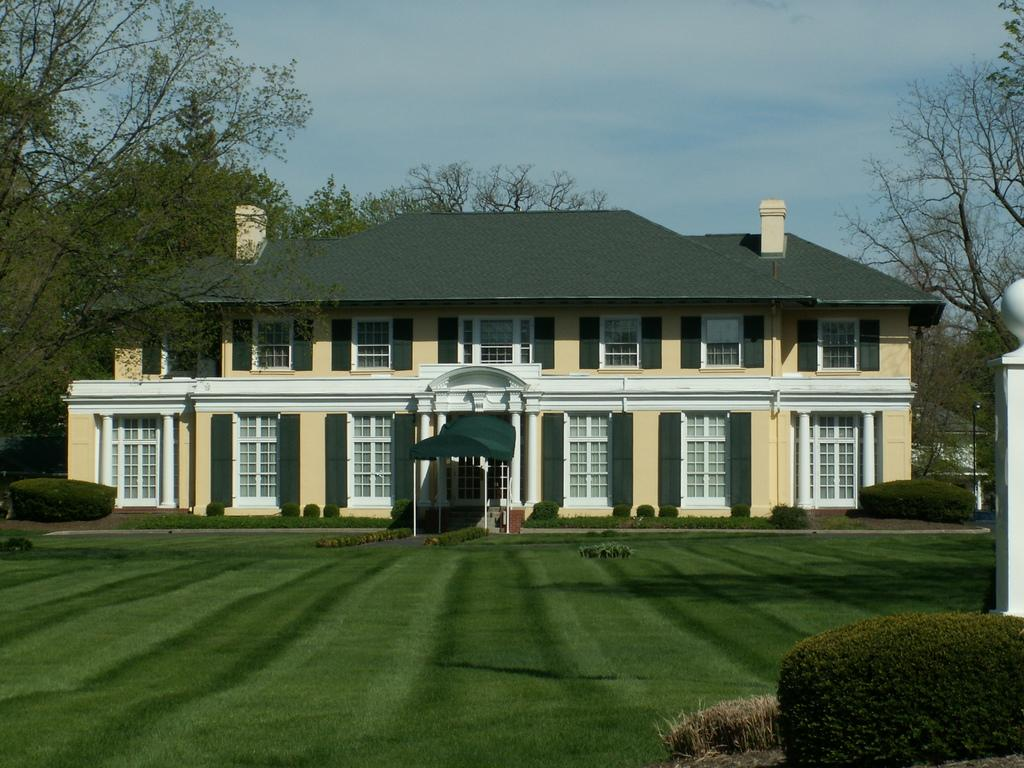What type of vegetation can be seen in the image? There are plants and trees in the image. What type of ground cover is present in the image? There is grass in the image. What type of structures are visible in the image? There are buildings in the image. What can be seen in the background of the image? The sky is visible in the background of the image. What type of adjustment is being made to the yoke in the image? There is no yoke present in the image, so no adjustment can be observed. What type of journey is depicted in the image? There is no journey depicted in the image; it features plants, grass, buildings, trees, and the sky. 